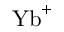Convert formula to latex. <formula><loc_0><loc_0><loc_500><loc_500>{ Y b } ^ { + }</formula> 